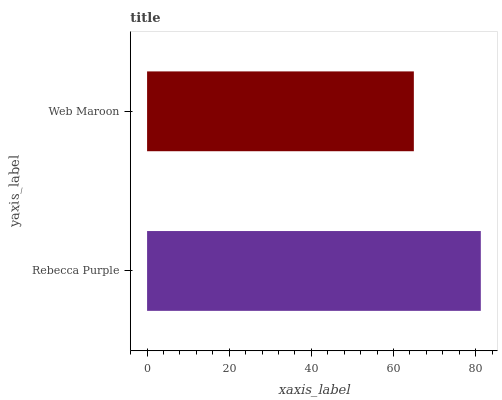Is Web Maroon the minimum?
Answer yes or no. Yes. Is Rebecca Purple the maximum?
Answer yes or no. Yes. Is Web Maroon the maximum?
Answer yes or no. No. Is Rebecca Purple greater than Web Maroon?
Answer yes or no. Yes. Is Web Maroon less than Rebecca Purple?
Answer yes or no. Yes. Is Web Maroon greater than Rebecca Purple?
Answer yes or no. No. Is Rebecca Purple less than Web Maroon?
Answer yes or no. No. Is Rebecca Purple the high median?
Answer yes or no. Yes. Is Web Maroon the low median?
Answer yes or no. Yes. Is Web Maroon the high median?
Answer yes or no. No. Is Rebecca Purple the low median?
Answer yes or no. No. 